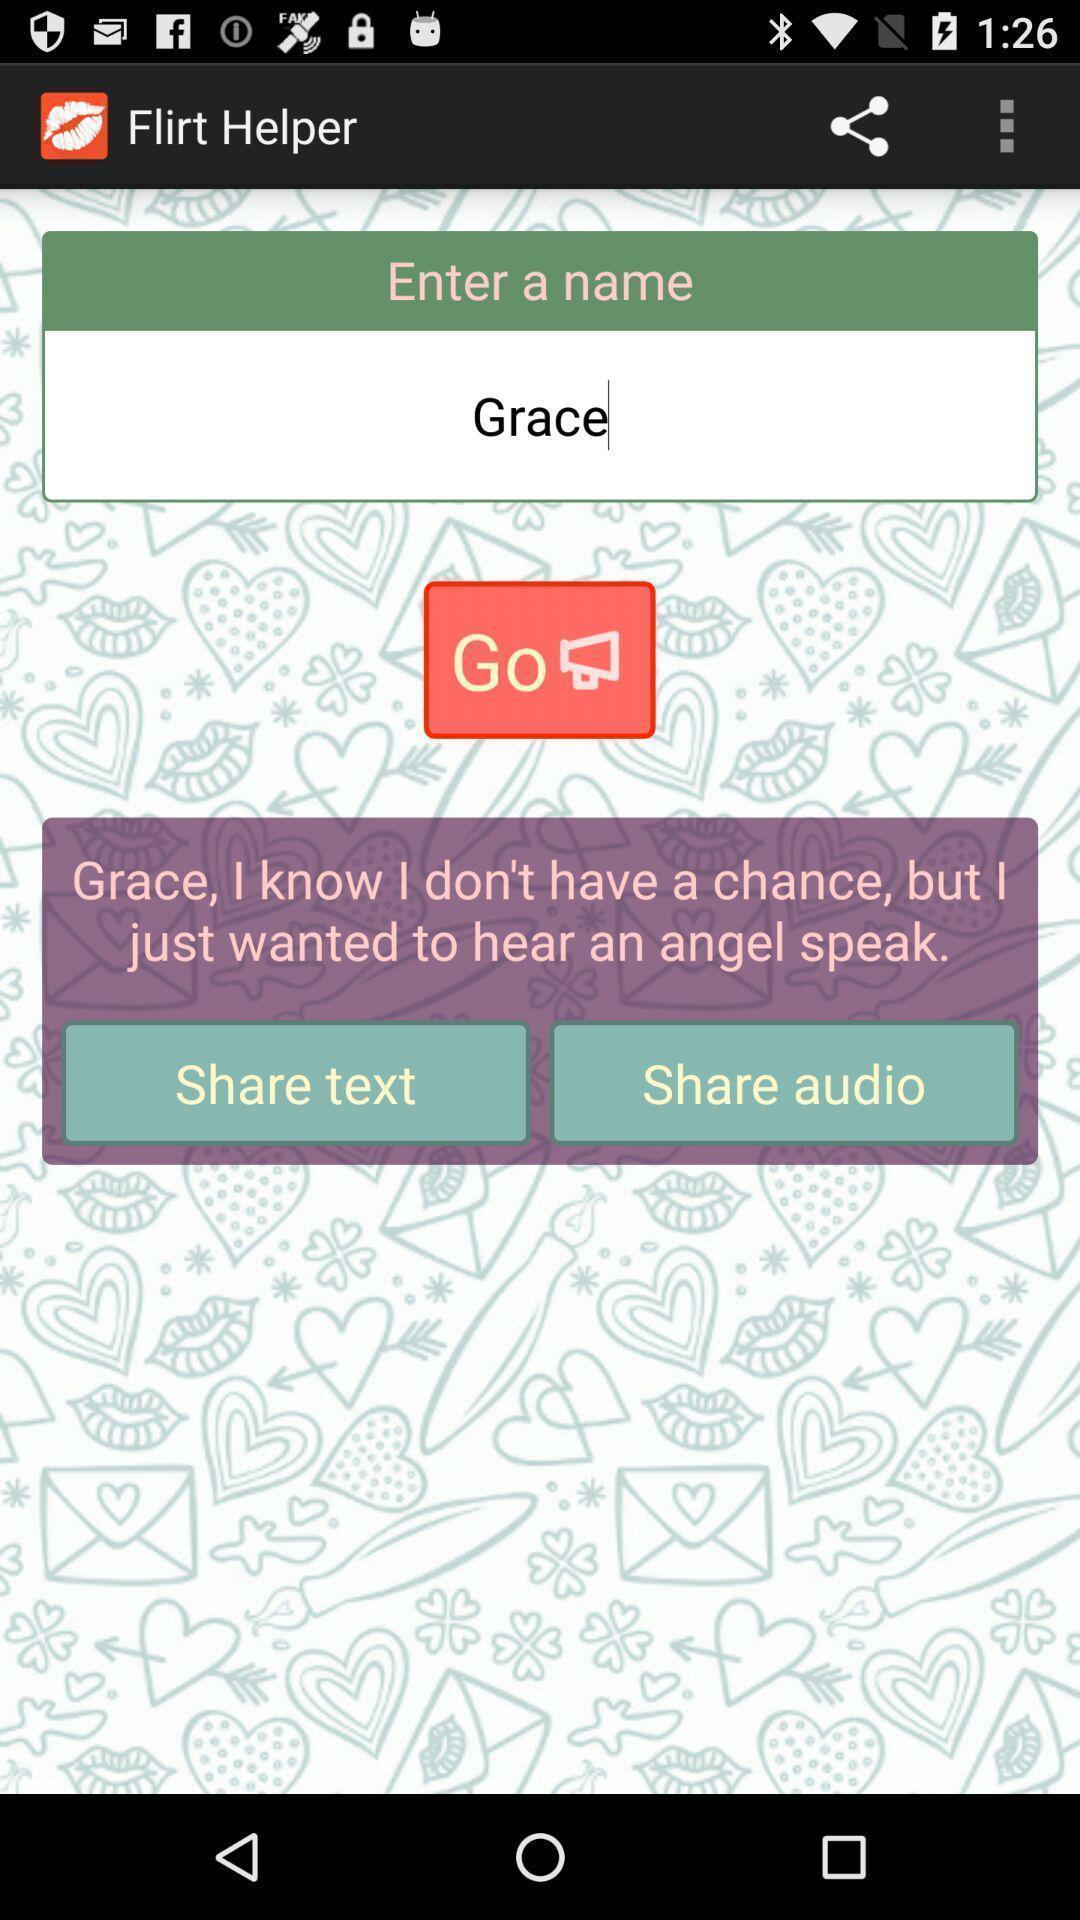Provide a description of this screenshot. Page displaying to share text and audio. 